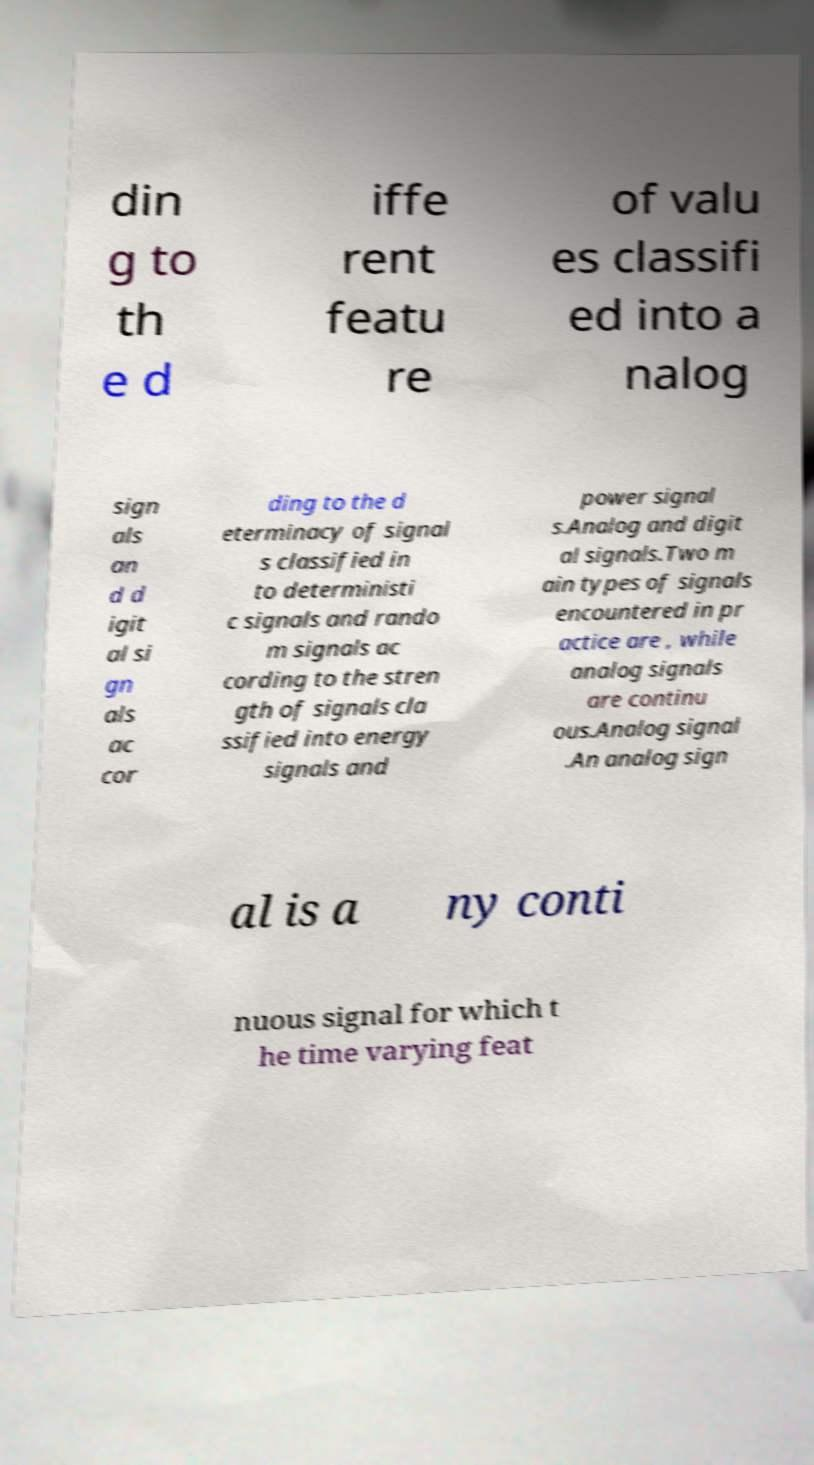Can you read and provide the text displayed in the image?This photo seems to have some interesting text. Can you extract and type it out for me? din g to th e d iffe rent featu re of valu es classifi ed into a nalog sign als an d d igit al si gn als ac cor ding to the d eterminacy of signal s classified in to deterministi c signals and rando m signals ac cording to the stren gth of signals cla ssified into energy signals and power signal s.Analog and digit al signals.Two m ain types of signals encountered in pr actice are , while analog signals are continu ous.Analog signal .An analog sign al is a ny conti nuous signal for which t he time varying feat 